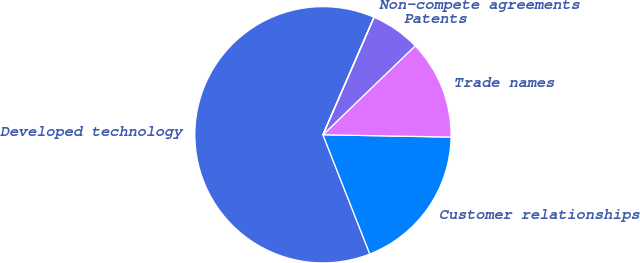Convert chart to OTSL. <chart><loc_0><loc_0><loc_500><loc_500><pie_chart><fcel>Developed technology<fcel>Customer relationships<fcel>Trade names<fcel>Patents<fcel>Non-compete agreements<nl><fcel>62.48%<fcel>18.75%<fcel>12.5%<fcel>6.26%<fcel>0.01%<nl></chart> 